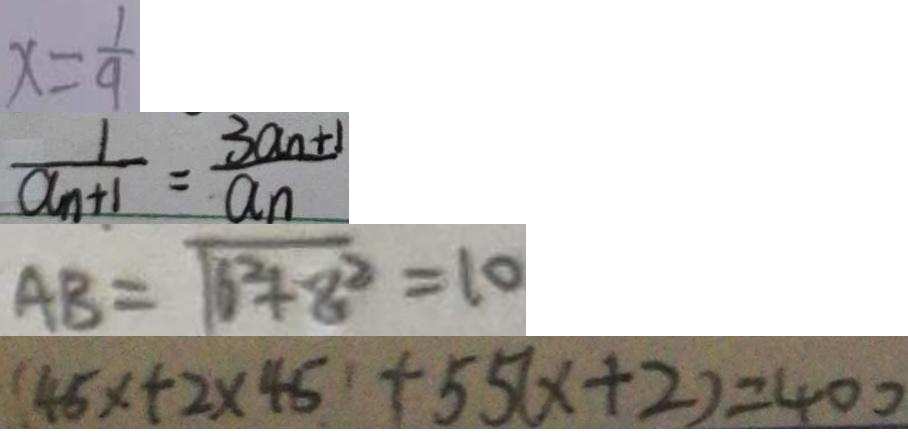<formula> <loc_0><loc_0><loc_500><loc_500>x = \frac { 1 } { 9 } 
 \frac { 1 } { a _ { n } + 1 } = \frac { 3 a _ { n } + 1 } { a _ { n } } 
 A B = \sqrt { 6 ^ { 2 } + 8 ^ { 2 } } = 1 0 
 ( 4 5 x + 2 \times 4 5 + 5 5 ( x + 2 ) = 4 0 0</formula> 